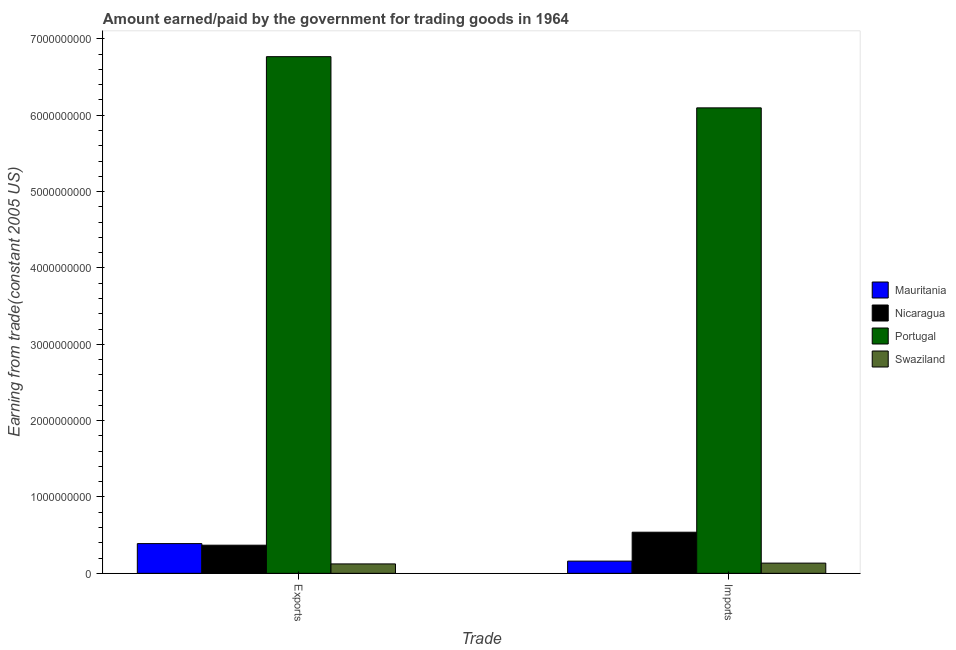How many groups of bars are there?
Give a very brief answer. 2. Are the number of bars on each tick of the X-axis equal?
Your answer should be very brief. Yes. How many bars are there on the 2nd tick from the left?
Your response must be concise. 4. What is the label of the 1st group of bars from the left?
Keep it short and to the point. Exports. What is the amount paid for imports in Portugal?
Provide a short and direct response. 6.10e+09. Across all countries, what is the maximum amount paid for imports?
Your answer should be compact. 6.10e+09. Across all countries, what is the minimum amount earned from exports?
Provide a succinct answer. 1.23e+08. In which country was the amount earned from exports minimum?
Offer a terse response. Swaziland. What is the total amount earned from exports in the graph?
Ensure brevity in your answer.  7.65e+09. What is the difference between the amount earned from exports in Swaziland and that in Mauritania?
Offer a very short reply. -2.66e+08. What is the difference between the amount earned from exports in Nicaragua and the amount paid for imports in Swaziland?
Offer a very short reply. 2.35e+08. What is the average amount earned from exports per country?
Offer a very short reply. 1.91e+09. What is the difference between the amount paid for imports and amount earned from exports in Mauritania?
Make the answer very short. -2.29e+08. What is the ratio of the amount earned from exports in Portugal to that in Nicaragua?
Your answer should be very brief. 18.36. Is the amount paid for imports in Swaziland less than that in Portugal?
Your answer should be compact. Yes. In how many countries, is the amount earned from exports greater than the average amount earned from exports taken over all countries?
Provide a short and direct response. 1. What does the 1st bar from the left in Imports represents?
Make the answer very short. Mauritania. What does the 3rd bar from the right in Imports represents?
Offer a very short reply. Nicaragua. How many bars are there?
Make the answer very short. 8. Are all the bars in the graph horizontal?
Ensure brevity in your answer.  No. What is the difference between two consecutive major ticks on the Y-axis?
Ensure brevity in your answer.  1.00e+09. Are the values on the major ticks of Y-axis written in scientific E-notation?
Your response must be concise. No. Does the graph contain any zero values?
Provide a short and direct response. No. What is the title of the graph?
Provide a succinct answer. Amount earned/paid by the government for trading goods in 1964. What is the label or title of the X-axis?
Offer a terse response. Trade. What is the label or title of the Y-axis?
Offer a very short reply. Earning from trade(constant 2005 US). What is the Earning from trade(constant 2005 US) of Mauritania in Exports?
Make the answer very short. 3.89e+08. What is the Earning from trade(constant 2005 US) in Nicaragua in Exports?
Keep it short and to the point. 3.68e+08. What is the Earning from trade(constant 2005 US) of Portugal in Exports?
Offer a very short reply. 6.77e+09. What is the Earning from trade(constant 2005 US) in Swaziland in Exports?
Keep it short and to the point. 1.23e+08. What is the Earning from trade(constant 2005 US) in Mauritania in Imports?
Provide a short and direct response. 1.60e+08. What is the Earning from trade(constant 2005 US) in Nicaragua in Imports?
Offer a terse response. 5.39e+08. What is the Earning from trade(constant 2005 US) of Portugal in Imports?
Make the answer very short. 6.10e+09. What is the Earning from trade(constant 2005 US) in Swaziland in Imports?
Provide a short and direct response. 1.34e+08. Across all Trade, what is the maximum Earning from trade(constant 2005 US) of Mauritania?
Your answer should be compact. 3.89e+08. Across all Trade, what is the maximum Earning from trade(constant 2005 US) of Nicaragua?
Your answer should be very brief. 5.39e+08. Across all Trade, what is the maximum Earning from trade(constant 2005 US) of Portugal?
Give a very brief answer. 6.77e+09. Across all Trade, what is the maximum Earning from trade(constant 2005 US) in Swaziland?
Your response must be concise. 1.34e+08. Across all Trade, what is the minimum Earning from trade(constant 2005 US) of Mauritania?
Offer a terse response. 1.60e+08. Across all Trade, what is the minimum Earning from trade(constant 2005 US) in Nicaragua?
Your answer should be compact. 3.68e+08. Across all Trade, what is the minimum Earning from trade(constant 2005 US) in Portugal?
Your response must be concise. 6.10e+09. Across all Trade, what is the minimum Earning from trade(constant 2005 US) of Swaziland?
Give a very brief answer. 1.23e+08. What is the total Earning from trade(constant 2005 US) of Mauritania in the graph?
Give a very brief answer. 5.49e+08. What is the total Earning from trade(constant 2005 US) of Nicaragua in the graph?
Your answer should be compact. 9.07e+08. What is the total Earning from trade(constant 2005 US) in Portugal in the graph?
Your answer should be compact. 1.29e+1. What is the total Earning from trade(constant 2005 US) in Swaziland in the graph?
Provide a succinct answer. 2.57e+08. What is the difference between the Earning from trade(constant 2005 US) of Mauritania in Exports and that in Imports?
Offer a very short reply. 2.29e+08. What is the difference between the Earning from trade(constant 2005 US) in Nicaragua in Exports and that in Imports?
Provide a short and direct response. -1.70e+08. What is the difference between the Earning from trade(constant 2005 US) in Portugal in Exports and that in Imports?
Offer a terse response. 6.71e+08. What is the difference between the Earning from trade(constant 2005 US) of Swaziland in Exports and that in Imports?
Keep it short and to the point. -1.06e+07. What is the difference between the Earning from trade(constant 2005 US) in Mauritania in Exports and the Earning from trade(constant 2005 US) in Nicaragua in Imports?
Give a very brief answer. -1.49e+08. What is the difference between the Earning from trade(constant 2005 US) of Mauritania in Exports and the Earning from trade(constant 2005 US) of Portugal in Imports?
Offer a very short reply. -5.71e+09. What is the difference between the Earning from trade(constant 2005 US) in Mauritania in Exports and the Earning from trade(constant 2005 US) in Swaziland in Imports?
Your response must be concise. 2.55e+08. What is the difference between the Earning from trade(constant 2005 US) in Nicaragua in Exports and the Earning from trade(constant 2005 US) in Portugal in Imports?
Provide a short and direct response. -5.73e+09. What is the difference between the Earning from trade(constant 2005 US) in Nicaragua in Exports and the Earning from trade(constant 2005 US) in Swaziland in Imports?
Your answer should be compact. 2.35e+08. What is the difference between the Earning from trade(constant 2005 US) in Portugal in Exports and the Earning from trade(constant 2005 US) in Swaziland in Imports?
Your answer should be compact. 6.63e+09. What is the average Earning from trade(constant 2005 US) in Mauritania per Trade?
Your answer should be compact. 2.75e+08. What is the average Earning from trade(constant 2005 US) in Nicaragua per Trade?
Offer a terse response. 4.54e+08. What is the average Earning from trade(constant 2005 US) in Portugal per Trade?
Keep it short and to the point. 6.43e+09. What is the average Earning from trade(constant 2005 US) in Swaziland per Trade?
Provide a short and direct response. 1.29e+08. What is the difference between the Earning from trade(constant 2005 US) in Mauritania and Earning from trade(constant 2005 US) in Nicaragua in Exports?
Offer a terse response. 2.08e+07. What is the difference between the Earning from trade(constant 2005 US) of Mauritania and Earning from trade(constant 2005 US) of Portugal in Exports?
Your answer should be very brief. -6.38e+09. What is the difference between the Earning from trade(constant 2005 US) of Mauritania and Earning from trade(constant 2005 US) of Swaziland in Exports?
Your answer should be compact. 2.66e+08. What is the difference between the Earning from trade(constant 2005 US) in Nicaragua and Earning from trade(constant 2005 US) in Portugal in Exports?
Your answer should be very brief. -6.40e+09. What is the difference between the Earning from trade(constant 2005 US) of Nicaragua and Earning from trade(constant 2005 US) of Swaziland in Exports?
Keep it short and to the point. 2.45e+08. What is the difference between the Earning from trade(constant 2005 US) in Portugal and Earning from trade(constant 2005 US) in Swaziland in Exports?
Your answer should be very brief. 6.64e+09. What is the difference between the Earning from trade(constant 2005 US) of Mauritania and Earning from trade(constant 2005 US) of Nicaragua in Imports?
Give a very brief answer. -3.79e+08. What is the difference between the Earning from trade(constant 2005 US) in Mauritania and Earning from trade(constant 2005 US) in Portugal in Imports?
Provide a succinct answer. -5.94e+09. What is the difference between the Earning from trade(constant 2005 US) in Mauritania and Earning from trade(constant 2005 US) in Swaziland in Imports?
Your response must be concise. 2.61e+07. What is the difference between the Earning from trade(constant 2005 US) of Nicaragua and Earning from trade(constant 2005 US) of Portugal in Imports?
Make the answer very short. -5.56e+09. What is the difference between the Earning from trade(constant 2005 US) of Nicaragua and Earning from trade(constant 2005 US) of Swaziland in Imports?
Give a very brief answer. 4.05e+08. What is the difference between the Earning from trade(constant 2005 US) in Portugal and Earning from trade(constant 2005 US) in Swaziland in Imports?
Give a very brief answer. 5.96e+09. What is the ratio of the Earning from trade(constant 2005 US) of Mauritania in Exports to that in Imports?
Your response must be concise. 2.43. What is the ratio of the Earning from trade(constant 2005 US) of Nicaragua in Exports to that in Imports?
Keep it short and to the point. 0.68. What is the ratio of the Earning from trade(constant 2005 US) in Portugal in Exports to that in Imports?
Make the answer very short. 1.11. What is the ratio of the Earning from trade(constant 2005 US) of Swaziland in Exports to that in Imports?
Your response must be concise. 0.92. What is the difference between the highest and the second highest Earning from trade(constant 2005 US) in Mauritania?
Your answer should be very brief. 2.29e+08. What is the difference between the highest and the second highest Earning from trade(constant 2005 US) of Nicaragua?
Offer a very short reply. 1.70e+08. What is the difference between the highest and the second highest Earning from trade(constant 2005 US) in Portugal?
Your response must be concise. 6.71e+08. What is the difference between the highest and the second highest Earning from trade(constant 2005 US) in Swaziland?
Provide a succinct answer. 1.06e+07. What is the difference between the highest and the lowest Earning from trade(constant 2005 US) of Mauritania?
Offer a terse response. 2.29e+08. What is the difference between the highest and the lowest Earning from trade(constant 2005 US) of Nicaragua?
Keep it short and to the point. 1.70e+08. What is the difference between the highest and the lowest Earning from trade(constant 2005 US) of Portugal?
Your answer should be compact. 6.71e+08. What is the difference between the highest and the lowest Earning from trade(constant 2005 US) of Swaziland?
Make the answer very short. 1.06e+07. 